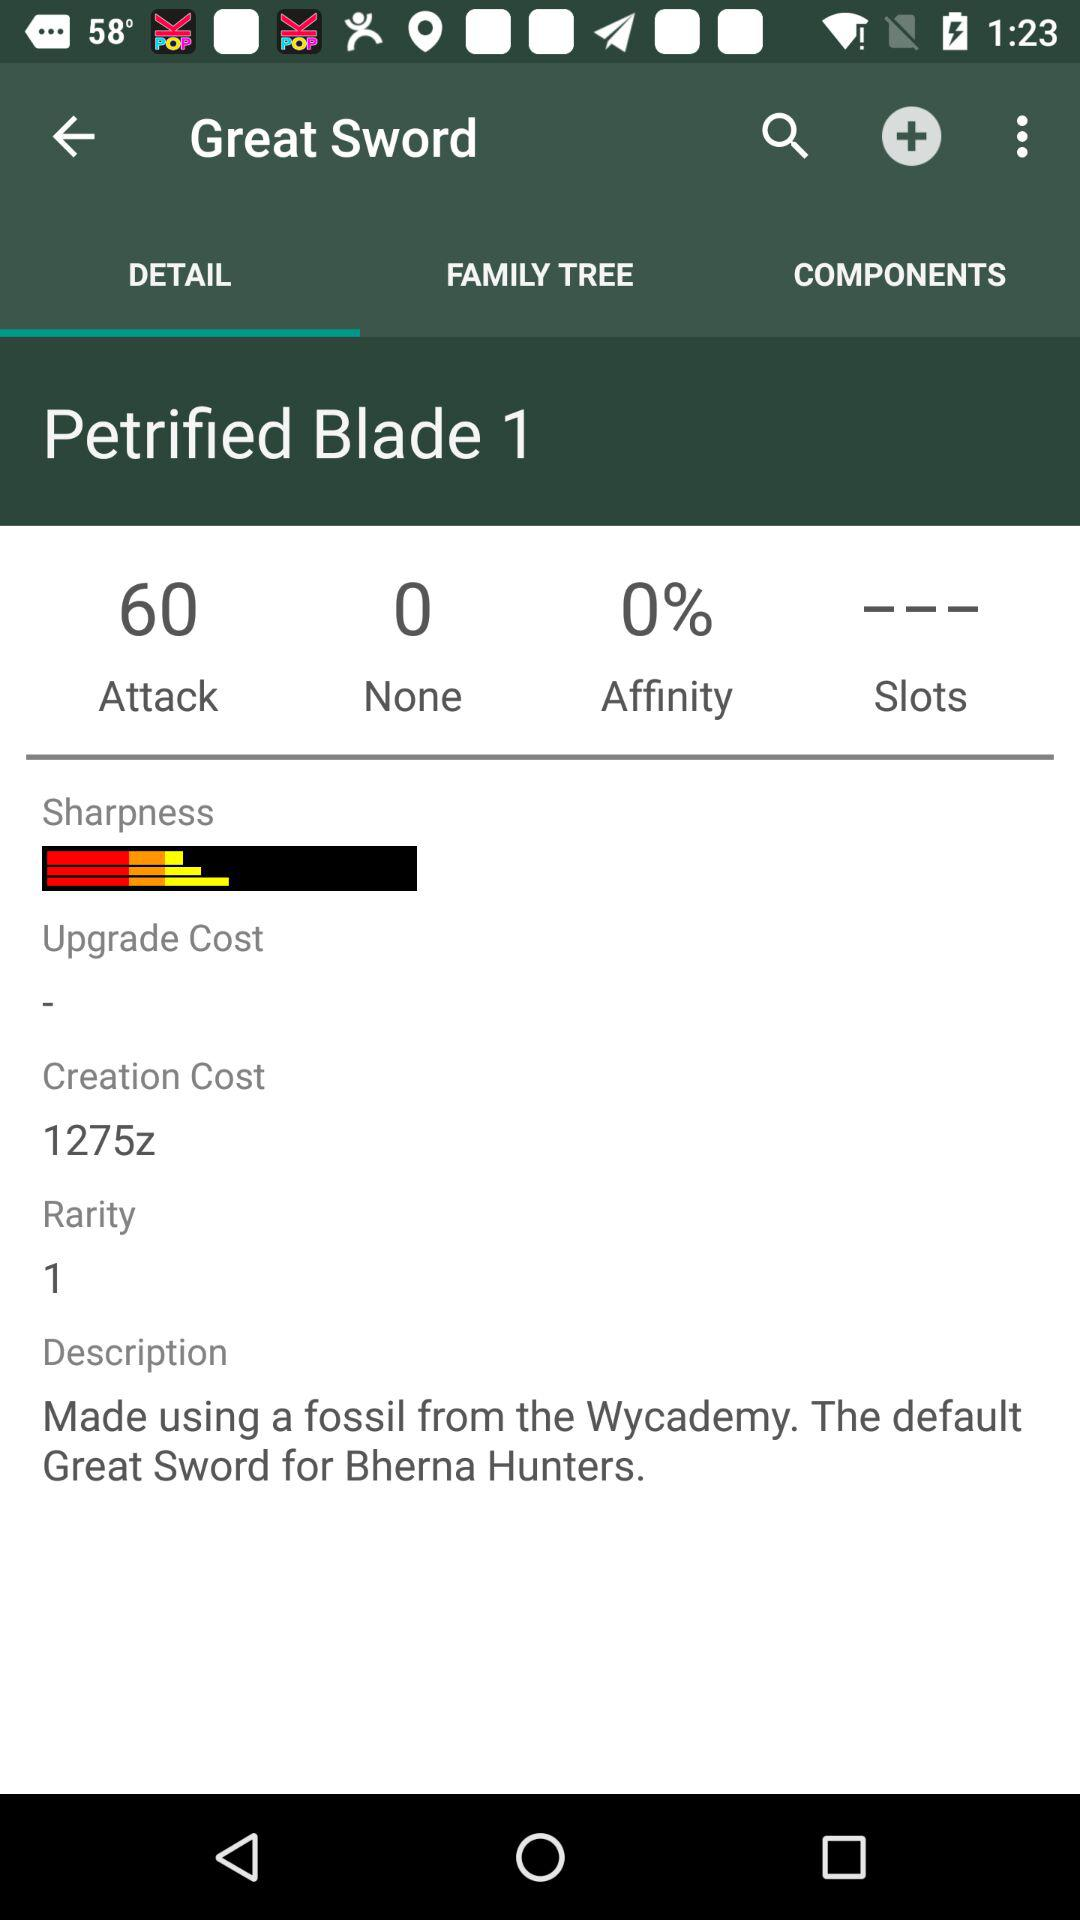What is the selected tab? The selected tab is "DETAIL". 